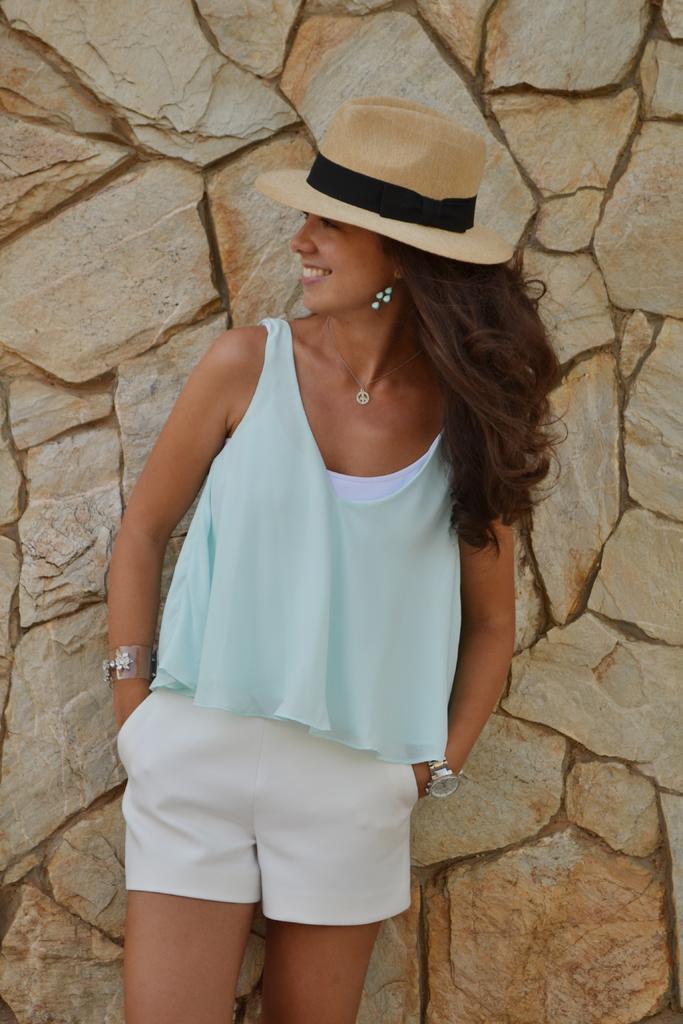Describe this image in one or two sentences. This image is taken outdoors. In the background there is a wall. In the middle of the image a woman in standing and she is with a smiling face. 